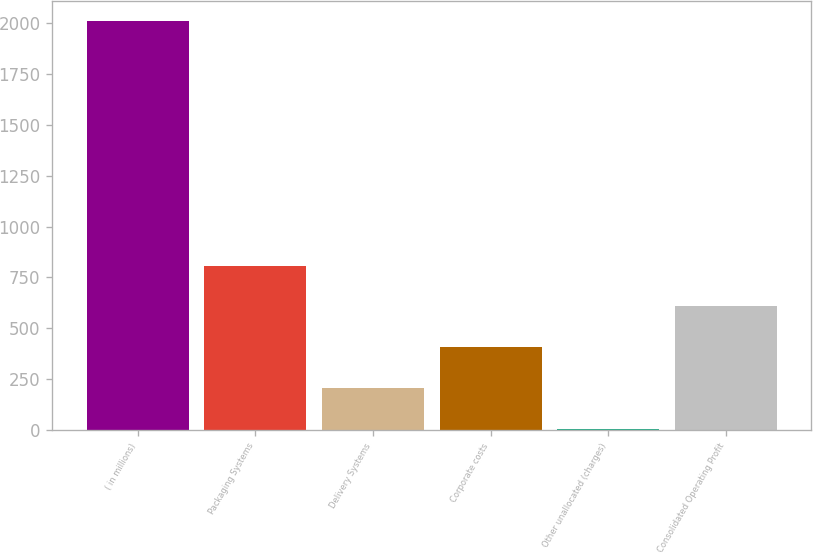<chart> <loc_0><loc_0><loc_500><loc_500><bar_chart><fcel>( in millions)<fcel>Packaging Systems<fcel>Delivery Systems<fcel>Corporate costs<fcel>Other unallocated (charges)<fcel>Consolidated Operating Profit<nl><fcel>2009<fcel>808.1<fcel>207.65<fcel>407.8<fcel>7.5<fcel>607.95<nl></chart> 